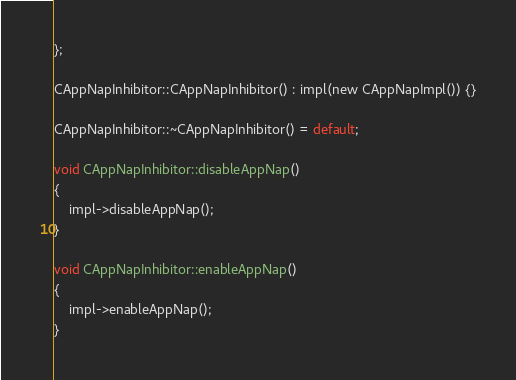Convert code to text. <code><loc_0><loc_0><loc_500><loc_500><_ObjectiveC_>};

CAppNapInhibitor::CAppNapInhibitor() : impl(new CAppNapImpl()) {}

CAppNapInhibitor::~CAppNapInhibitor() = default;

void CAppNapInhibitor::disableAppNap()
{
    impl->disableAppNap();
}

void CAppNapInhibitor::enableAppNap()
{
    impl->enableAppNap();
}
</code> 